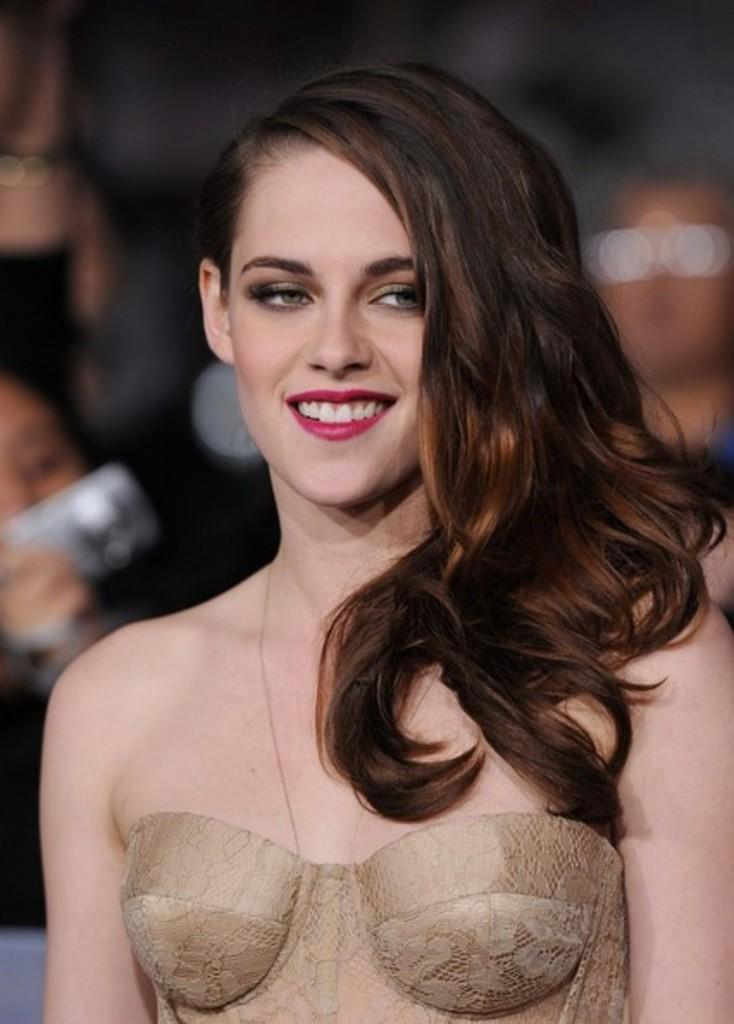Who is the main subject in the image? There is a woman in the image. What is the woman wearing? The woman is wearing a cream dress. What is the woman's facial expression? The woman is smiling. What can be seen in the background of the image? There is a group of people in the background of the image. How would you describe the quality of the image? The image is blurry. What type of trucks can be seen in the image? There are no trucks present in the image. What is the flavor of the woman's body in the image? The woman's body does not have a flavor, as it is not a food item. 